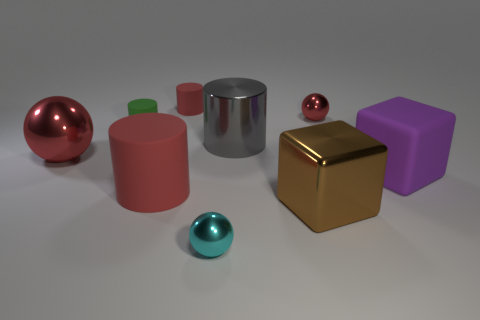There is another object that is the same shape as the large brown metal thing; what color is it?
Your response must be concise. Purple. The cyan shiny object has what size?
Give a very brief answer. Small. Are there fewer tiny cyan objects that are in front of the cyan metal thing than cubes?
Provide a short and direct response. Yes. Is the material of the purple thing the same as the green cylinder left of the large brown metal block?
Offer a very short reply. Yes. There is a brown thing that is in front of the large metallic sphere behind the large matte cube; are there any tiny metal objects to the right of it?
Give a very brief answer. Yes. What color is the big cylinder that is the same material as the big purple object?
Provide a short and direct response. Red. What is the size of the sphere that is to the right of the tiny red matte thing and behind the large rubber cylinder?
Offer a very short reply. Small. Are there fewer tiny shiny things that are in front of the big gray cylinder than spheres that are behind the big matte block?
Keep it short and to the point. Yes. Are the small cylinder that is in front of the small red matte thing and the small red thing that is to the right of the big gray cylinder made of the same material?
Make the answer very short. No. What material is the large object that is the same color as the large sphere?
Your answer should be very brief. Rubber. 